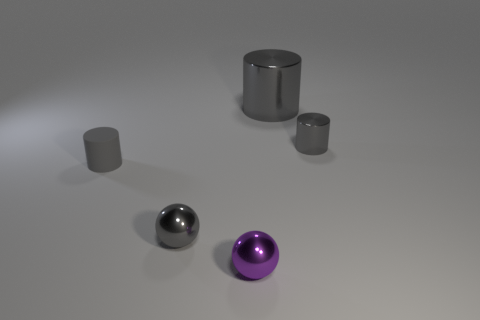How many gray cylinders must be subtracted to get 1 gray cylinders? 2 Add 1 tiny gray balls. How many objects exist? 6 Subtract all spheres. How many objects are left? 3 Subtract all tiny gray rubber cylinders. Subtract all tiny gray metallic cylinders. How many objects are left? 3 Add 2 rubber things. How many rubber things are left? 3 Add 2 big metal cylinders. How many big metal cylinders exist? 3 Subtract 0 purple cylinders. How many objects are left? 5 